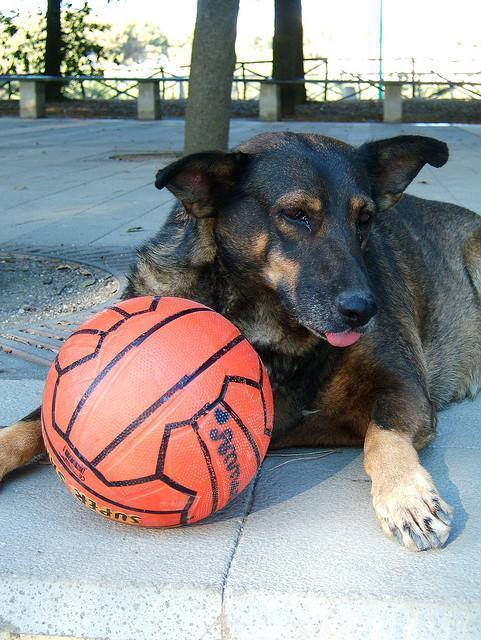How many benches are in the photo?
Give a very brief answer. 2. How many zebras are there?
Give a very brief answer. 0. 